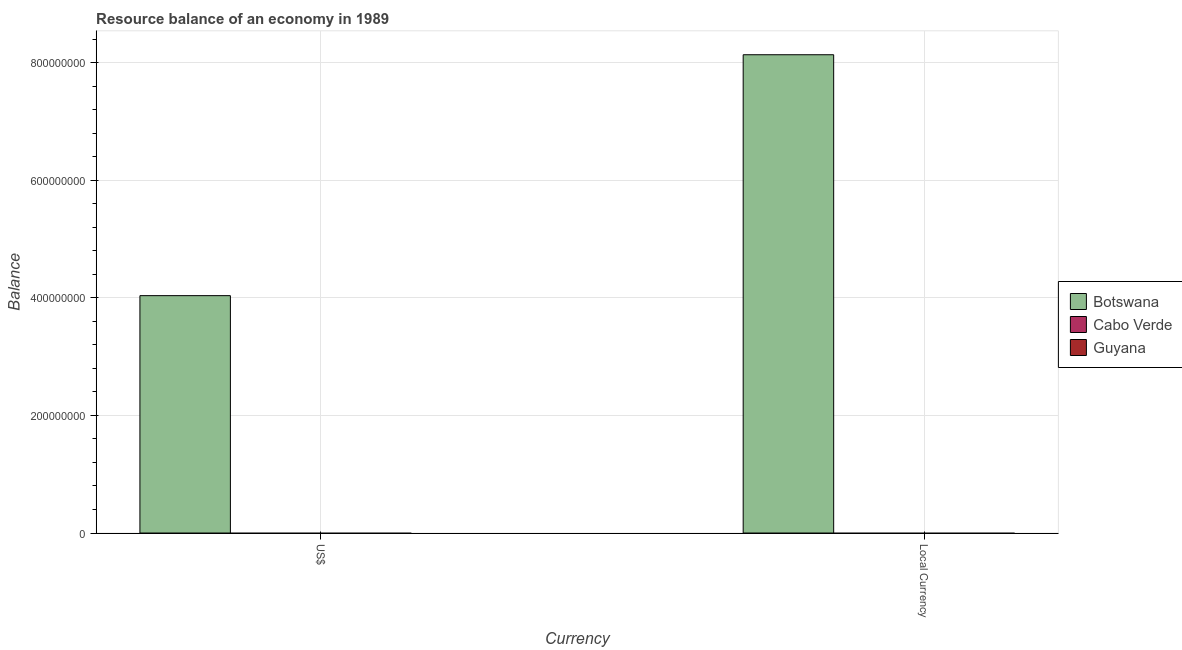How many different coloured bars are there?
Provide a short and direct response. 1. How many bars are there on the 2nd tick from the left?
Make the answer very short. 1. What is the label of the 1st group of bars from the left?
Your answer should be compact. US$. Across all countries, what is the maximum resource balance in us$?
Make the answer very short. 4.04e+08. In which country was the resource balance in constant us$ maximum?
Your answer should be very brief. Botswana. What is the total resource balance in constant us$ in the graph?
Your response must be concise. 8.13e+08. What is the difference between the resource balance in us$ in Botswana and the resource balance in constant us$ in Cabo Verde?
Offer a terse response. 4.04e+08. What is the average resource balance in constant us$ per country?
Provide a short and direct response. 2.71e+08. What is the difference between the resource balance in us$ and resource balance in constant us$ in Botswana?
Give a very brief answer. -4.10e+08. Are all the bars in the graph horizontal?
Provide a succinct answer. No. How many countries are there in the graph?
Your answer should be very brief. 3. Does the graph contain any zero values?
Ensure brevity in your answer.  Yes. Where does the legend appear in the graph?
Provide a succinct answer. Center right. What is the title of the graph?
Provide a succinct answer. Resource balance of an economy in 1989. Does "Swaziland" appear as one of the legend labels in the graph?
Keep it short and to the point. No. What is the label or title of the X-axis?
Keep it short and to the point. Currency. What is the label or title of the Y-axis?
Your answer should be very brief. Balance. What is the Balance in Botswana in US$?
Offer a terse response. 4.04e+08. What is the Balance of Guyana in US$?
Your answer should be compact. 0. What is the Balance of Botswana in Local Currency?
Your response must be concise. 8.13e+08. Across all Currency, what is the maximum Balance in Botswana?
Offer a very short reply. 8.13e+08. Across all Currency, what is the minimum Balance in Botswana?
Your answer should be compact. 4.04e+08. What is the total Balance of Botswana in the graph?
Give a very brief answer. 1.22e+09. What is the difference between the Balance of Botswana in US$ and that in Local Currency?
Keep it short and to the point. -4.10e+08. What is the average Balance in Botswana per Currency?
Your answer should be compact. 6.08e+08. What is the average Balance of Cabo Verde per Currency?
Your answer should be compact. 0. What is the ratio of the Balance in Botswana in US$ to that in Local Currency?
Your response must be concise. 0.5. What is the difference between the highest and the second highest Balance in Botswana?
Offer a very short reply. 4.10e+08. What is the difference between the highest and the lowest Balance of Botswana?
Offer a very short reply. 4.10e+08. 